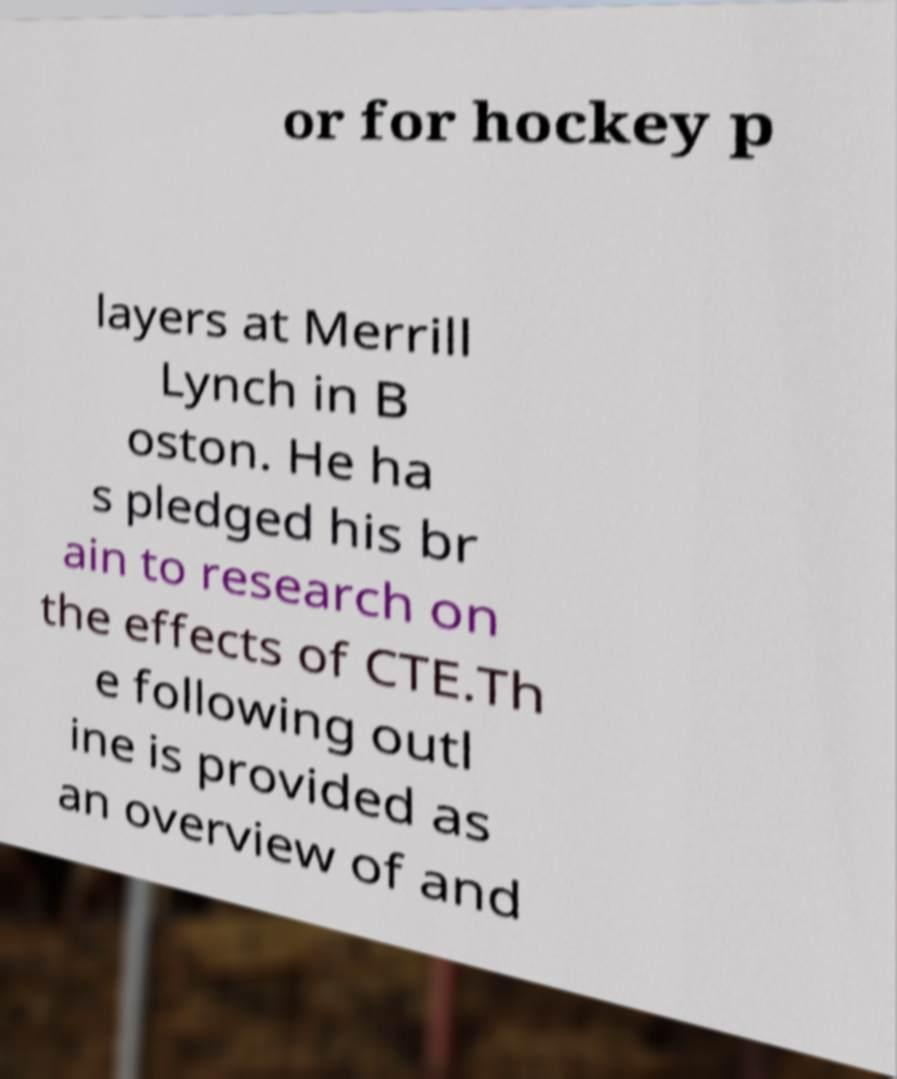What messages or text are displayed in this image? I need them in a readable, typed format. or for hockey p layers at Merrill Lynch in B oston. He ha s pledged his br ain to research on the effects of CTE.Th e following outl ine is provided as an overview of and 